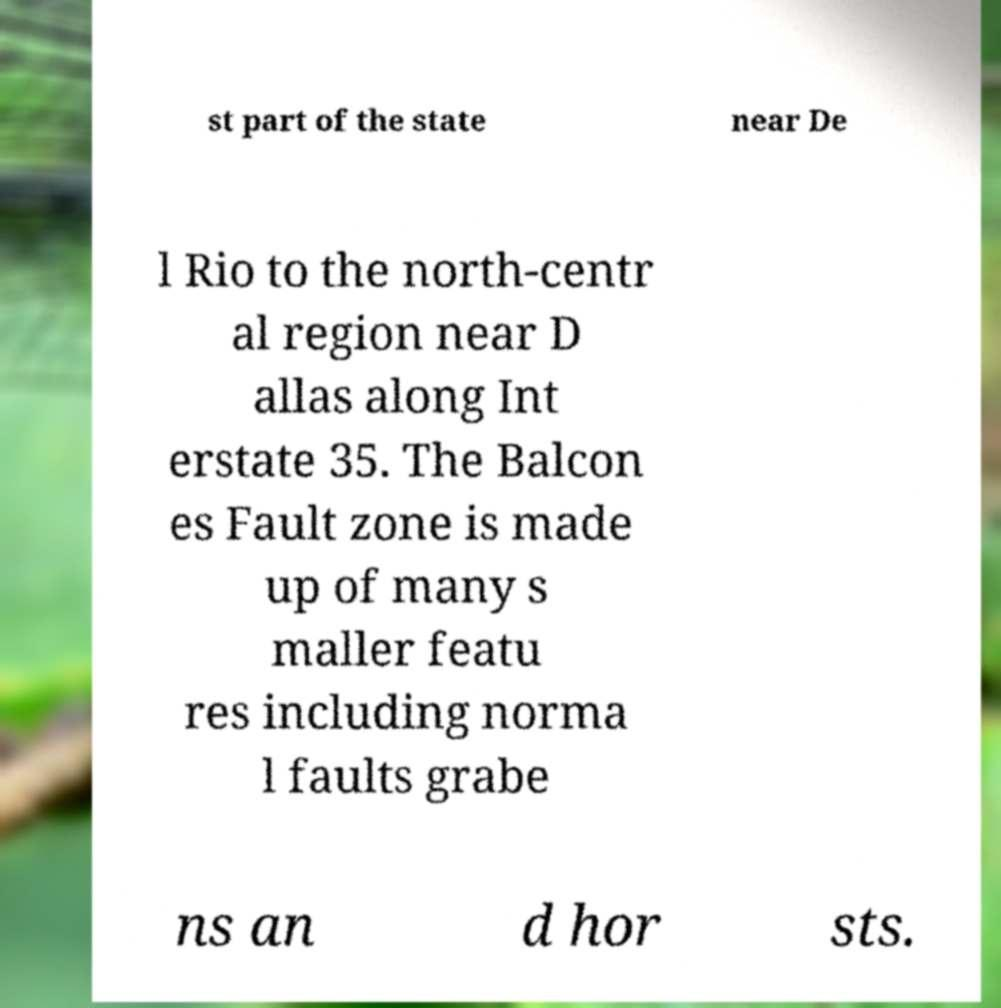Could you assist in decoding the text presented in this image and type it out clearly? st part of the state near De l Rio to the north-centr al region near D allas along Int erstate 35. The Balcon es Fault zone is made up of many s maller featu res including norma l faults grabe ns an d hor sts. 